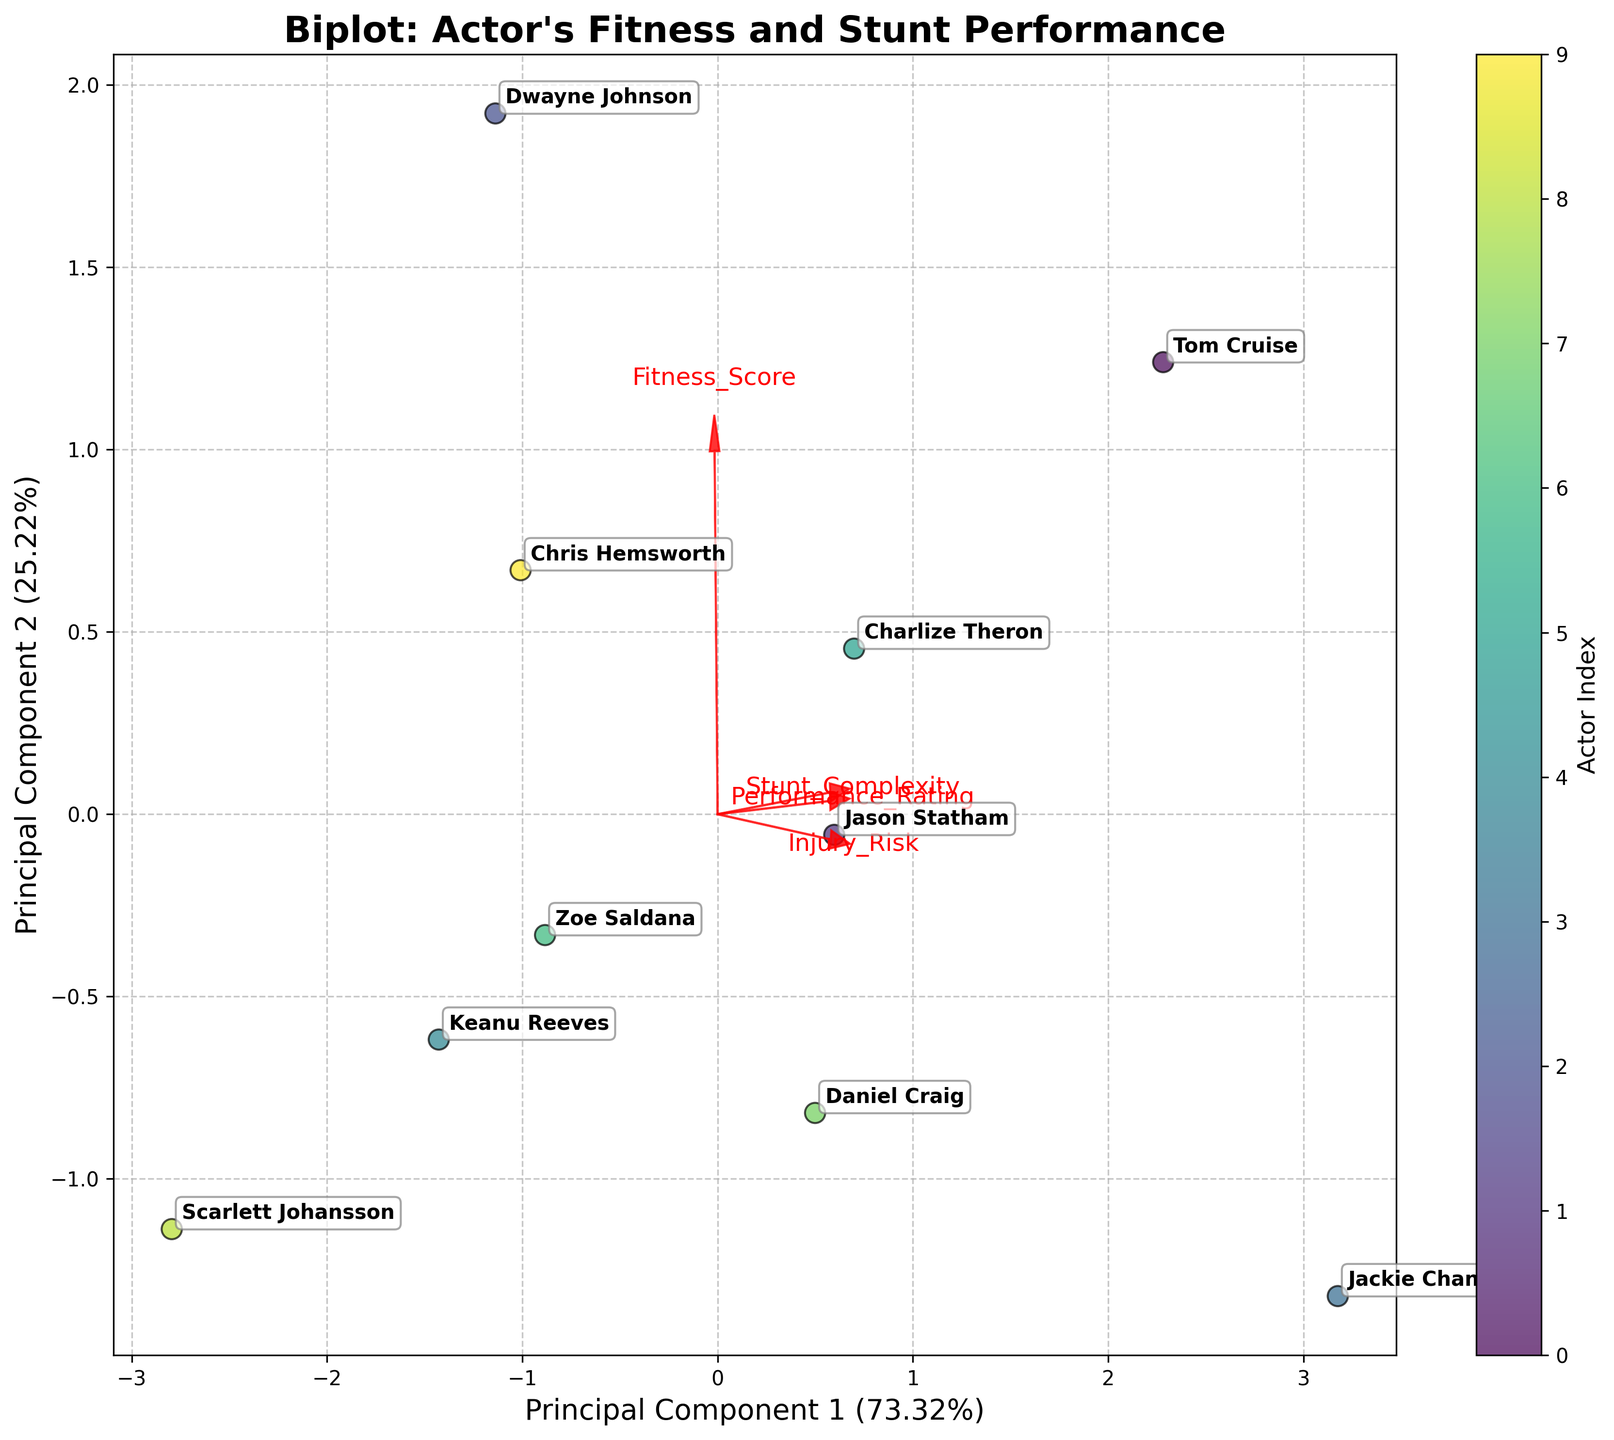How many principal components are shown in the plot? The plot displays two principal components, which are labeled on the x and y axes as Principal Component 1 and Principal Component 2.
Answer: 2 What is the title of the plot? The title is displayed at the top of the plot, and it reads "Biplot: Actor's Fitness and Stunt Performance."
Answer: Biplot: Actor's Fitness and Stunt Performance Which actor has the highest Performance Rating near the top right quadrant? By looking at the annotations near the top right quadrant, we can identify that Jackie Chan is positioned in that area. According to the data, Jackie Chan has a Performance Rating of 9.8, which is the highest among all actors.
Answer: Jackie Chan In which direction does the Fitness_Score vector point? The Fitness_Score vector is indicated by a red arrow starting at the origin and extending towards the right. This shows that the Fitness_Score points towards the right side of the plot.
Answer: Right Which two features seem to correlate most positively based on the arrow directions? To determine which features correlate positively, we examine the direction of the arrows. When arrows point in similar directions, it indicates a positive correlation. In this plot, Fitness_Score and Performance_Rating arrows are close to each other and, therefore, appear to correlate most positively.
Answer: Fitness_Score and Performance_Rating Which actor appears closest to the center of the plot, and what does this suggest? The actor closest to the center of the plot is Keanu Reeves. Being close to the center suggests his features (Fitness_Score, Stunt_Complexity, Injury_Risk, Performance_Rating) are near the mean values for all actors.
Answer: Keanu Reeves Which feature seems to have the strongest influence on the first principal component? We determine the feature with the strongest influence by seeing which arrow aligns most closely with the x-axis. The Fitness_Score arrow is almost parallel to the x-axis, indicating it has a strong influence on the first principal component.
Answer: Fitness_Score Which stunt type is performed by the actor who is farthest to the right on the plot? The actor farthest to the right is Tom Cruise, as indicated by his annotation. According to the data provided, Tom Cruise performs Aerial stunts.
Answer: Aerial Compare the positions of Jason Statham and Dwayne Johnson in the plot—who has a higher Fitness_Score? By examining the plot, we see that Dwayne Johnson is positioned more to the right than Jason Statham. Since the Fitness_Score vector points to the right, this indicates Dwayne Johnson has a higher Fitness_Score.
Answer: Dwayne Johnson 